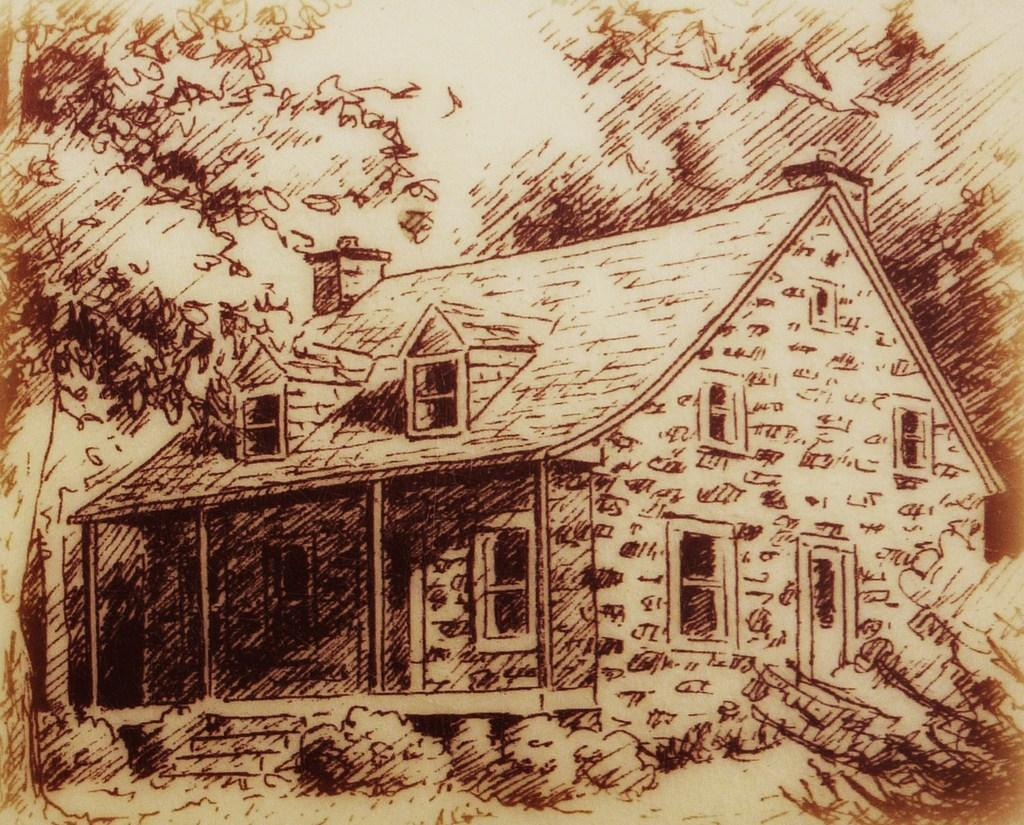What structure is shown in the image? There is a depiction of a house in the image. Are there any architectural features visible in the image? Yes, there are stairs in the image. What type of vegetation can be seen in the image? There are plants and a tree in the image. What hobbies does the robin engage in while sitting on the feather in the image? There is no robin or feather present in the image, so it is not possible to answer that question. 